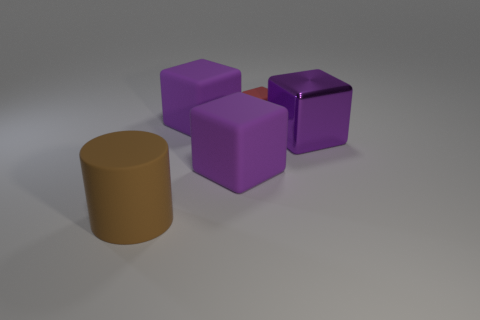Subtract all brown balls. How many purple cubes are left? 3 Add 2 red rubber objects. How many objects exist? 7 Subtract all cylinders. How many objects are left? 4 Add 4 purple metal cylinders. How many purple metal cylinders exist? 4 Subtract 0 yellow cylinders. How many objects are left? 5 Subtract all large purple things. Subtract all small red cubes. How many objects are left? 1 Add 2 rubber blocks. How many rubber blocks are left? 5 